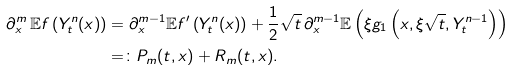<formula> <loc_0><loc_0><loc_500><loc_500>\partial _ { x } ^ { m } \, \mathbb { E } f \left ( Y ^ { n } _ { t } ( x ) \right ) & = \partial _ { x } ^ { m - 1 } \mathbb { E } f ^ { \prime } \left ( Y ^ { n } _ { t } ( x ) \right ) + \frac { 1 } { 2 } \sqrt { t } \, \partial _ { x } ^ { m - 1 } \mathbb { E } \left ( \xi g _ { 1 } \left ( x , \xi \sqrt { t } , Y ^ { n - 1 } _ { t } \right ) \right ) \\ & = \colon P _ { m } ( t , x ) + R _ { m } ( t , x ) .</formula> 